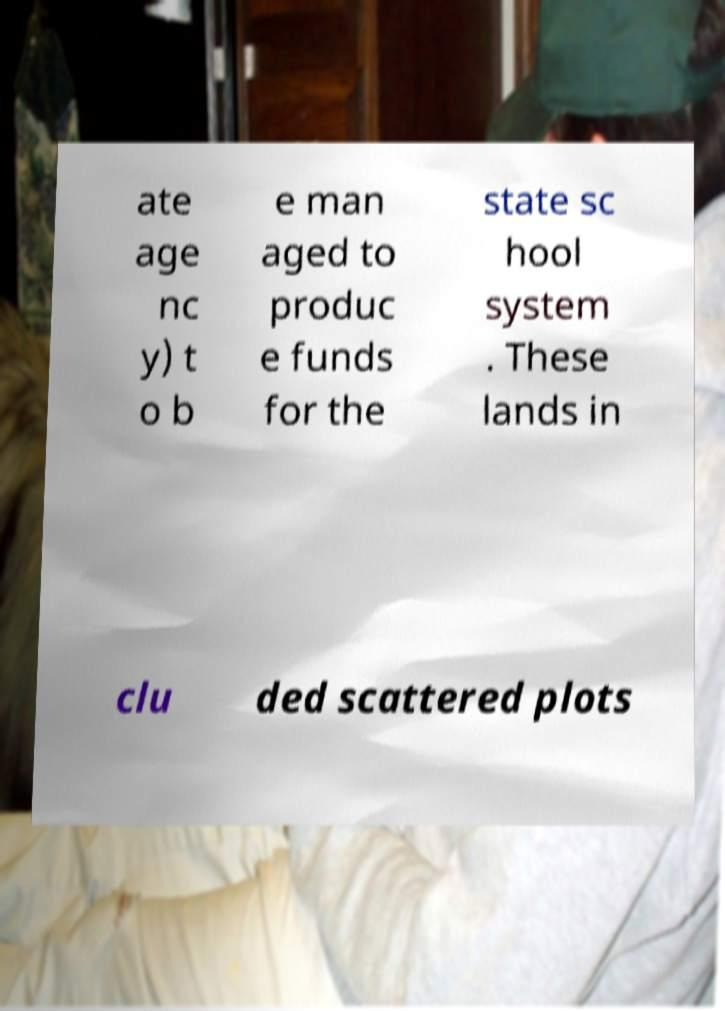Please read and relay the text visible in this image. What does it say? ate age nc y) t o b e man aged to produc e funds for the state sc hool system . These lands in clu ded scattered plots 